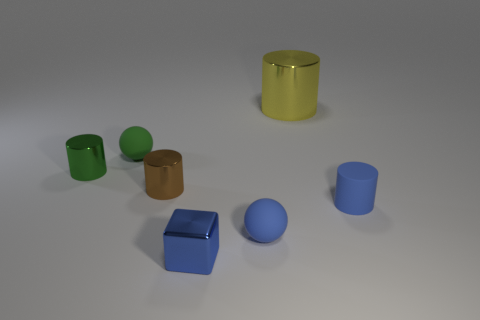Add 2 tiny spheres. How many objects exist? 9 Subtract all balls. How many objects are left? 5 Subtract all small brown metal objects. Subtract all small brown things. How many objects are left? 5 Add 3 big yellow cylinders. How many big yellow cylinders are left? 4 Add 2 tiny blue cylinders. How many tiny blue cylinders exist? 3 Subtract 0 red cylinders. How many objects are left? 7 